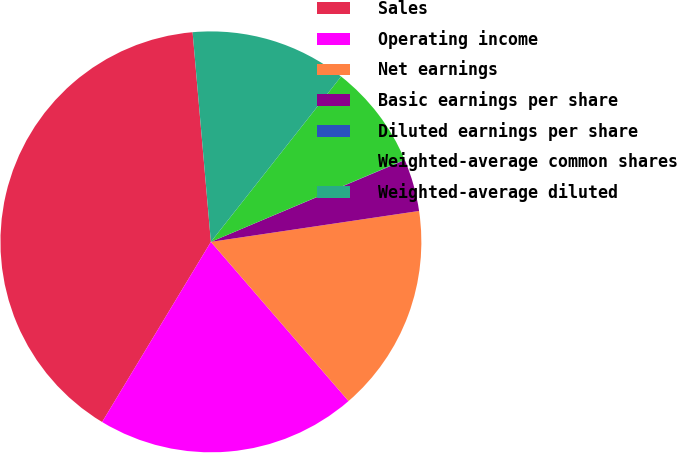Convert chart. <chart><loc_0><loc_0><loc_500><loc_500><pie_chart><fcel>Sales<fcel>Operating income<fcel>Net earnings<fcel>Basic earnings per share<fcel>Diluted earnings per share<fcel>Weighted-average common shares<fcel>Weighted-average diluted<nl><fcel>39.97%<fcel>19.99%<fcel>16.0%<fcel>4.01%<fcel>0.02%<fcel>8.01%<fcel>12.0%<nl></chart> 